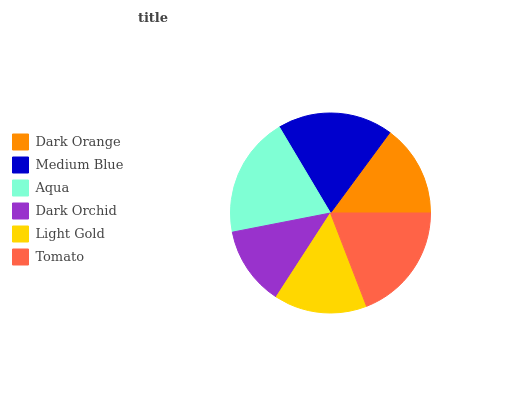Is Dark Orchid the minimum?
Answer yes or no. Yes. Is Aqua the maximum?
Answer yes or no. Yes. Is Medium Blue the minimum?
Answer yes or no. No. Is Medium Blue the maximum?
Answer yes or no. No. Is Medium Blue greater than Dark Orange?
Answer yes or no. Yes. Is Dark Orange less than Medium Blue?
Answer yes or no. Yes. Is Dark Orange greater than Medium Blue?
Answer yes or no. No. Is Medium Blue less than Dark Orange?
Answer yes or no. No. Is Medium Blue the high median?
Answer yes or no. Yes. Is Light Gold the low median?
Answer yes or no. Yes. Is Aqua the high median?
Answer yes or no. No. Is Aqua the low median?
Answer yes or no. No. 